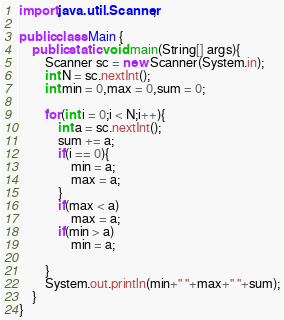Convert code to text. <code><loc_0><loc_0><loc_500><loc_500><_Java_>import java.util.Scanner;

public class Main {
	public static void main(String[] args){
		Scanner sc = new Scanner(System.in);
		int N = sc.nextInt();
		int min = 0,max = 0,sum = 0;
		
		for(int i = 0;i < N;i++){
			int a = sc.nextInt();
			sum += a;
			if(i == 0){
				min = a;
				max = a;
			}
			if(max < a)
				max = a;
			if(min > a)
				min = a;
			
		}
		System.out.println(min+" "+max+" "+sum);
	}
}</code> 